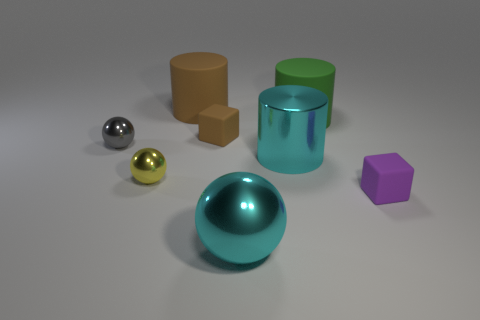How many green cubes are the same size as the yellow thing?
Offer a terse response. 0. The large rubber thing in front of the big brown cylinder that is left of the brown block is what shape?
Provide a short and direct response. Cylinder. The tiny object to the right of the rubber block on the left side of the large cylinder in front of the small gray metallic object is what shape?
Your answer should be very brief. Cube. How many brown objects are the same shape as the tiny purple rubber object?
Provide a succinct answer. 1. There is a small shiny thing to the left of the yellow thing; how many purple matte objects are behind it?
Offer a terse response. 0. What number of shiny things are either large brown things or large green things?
Your answer should be compact. 0. Is there a brown block that has the same material as the large brown thing?
Keep it short and to the point. Yes. What number of things are either metal objects that are in front of the tiny purple matte thing or metal objects that are left of the cyan metallic sphere?
Offer a terse response. 3. There is a cylinder in front of the large green cylinder; is its color the same as the large sphere?
Keep it short and to the point. Yes. How many other things are there of the same color as the large ball?
Offer a very short reply. 1. 